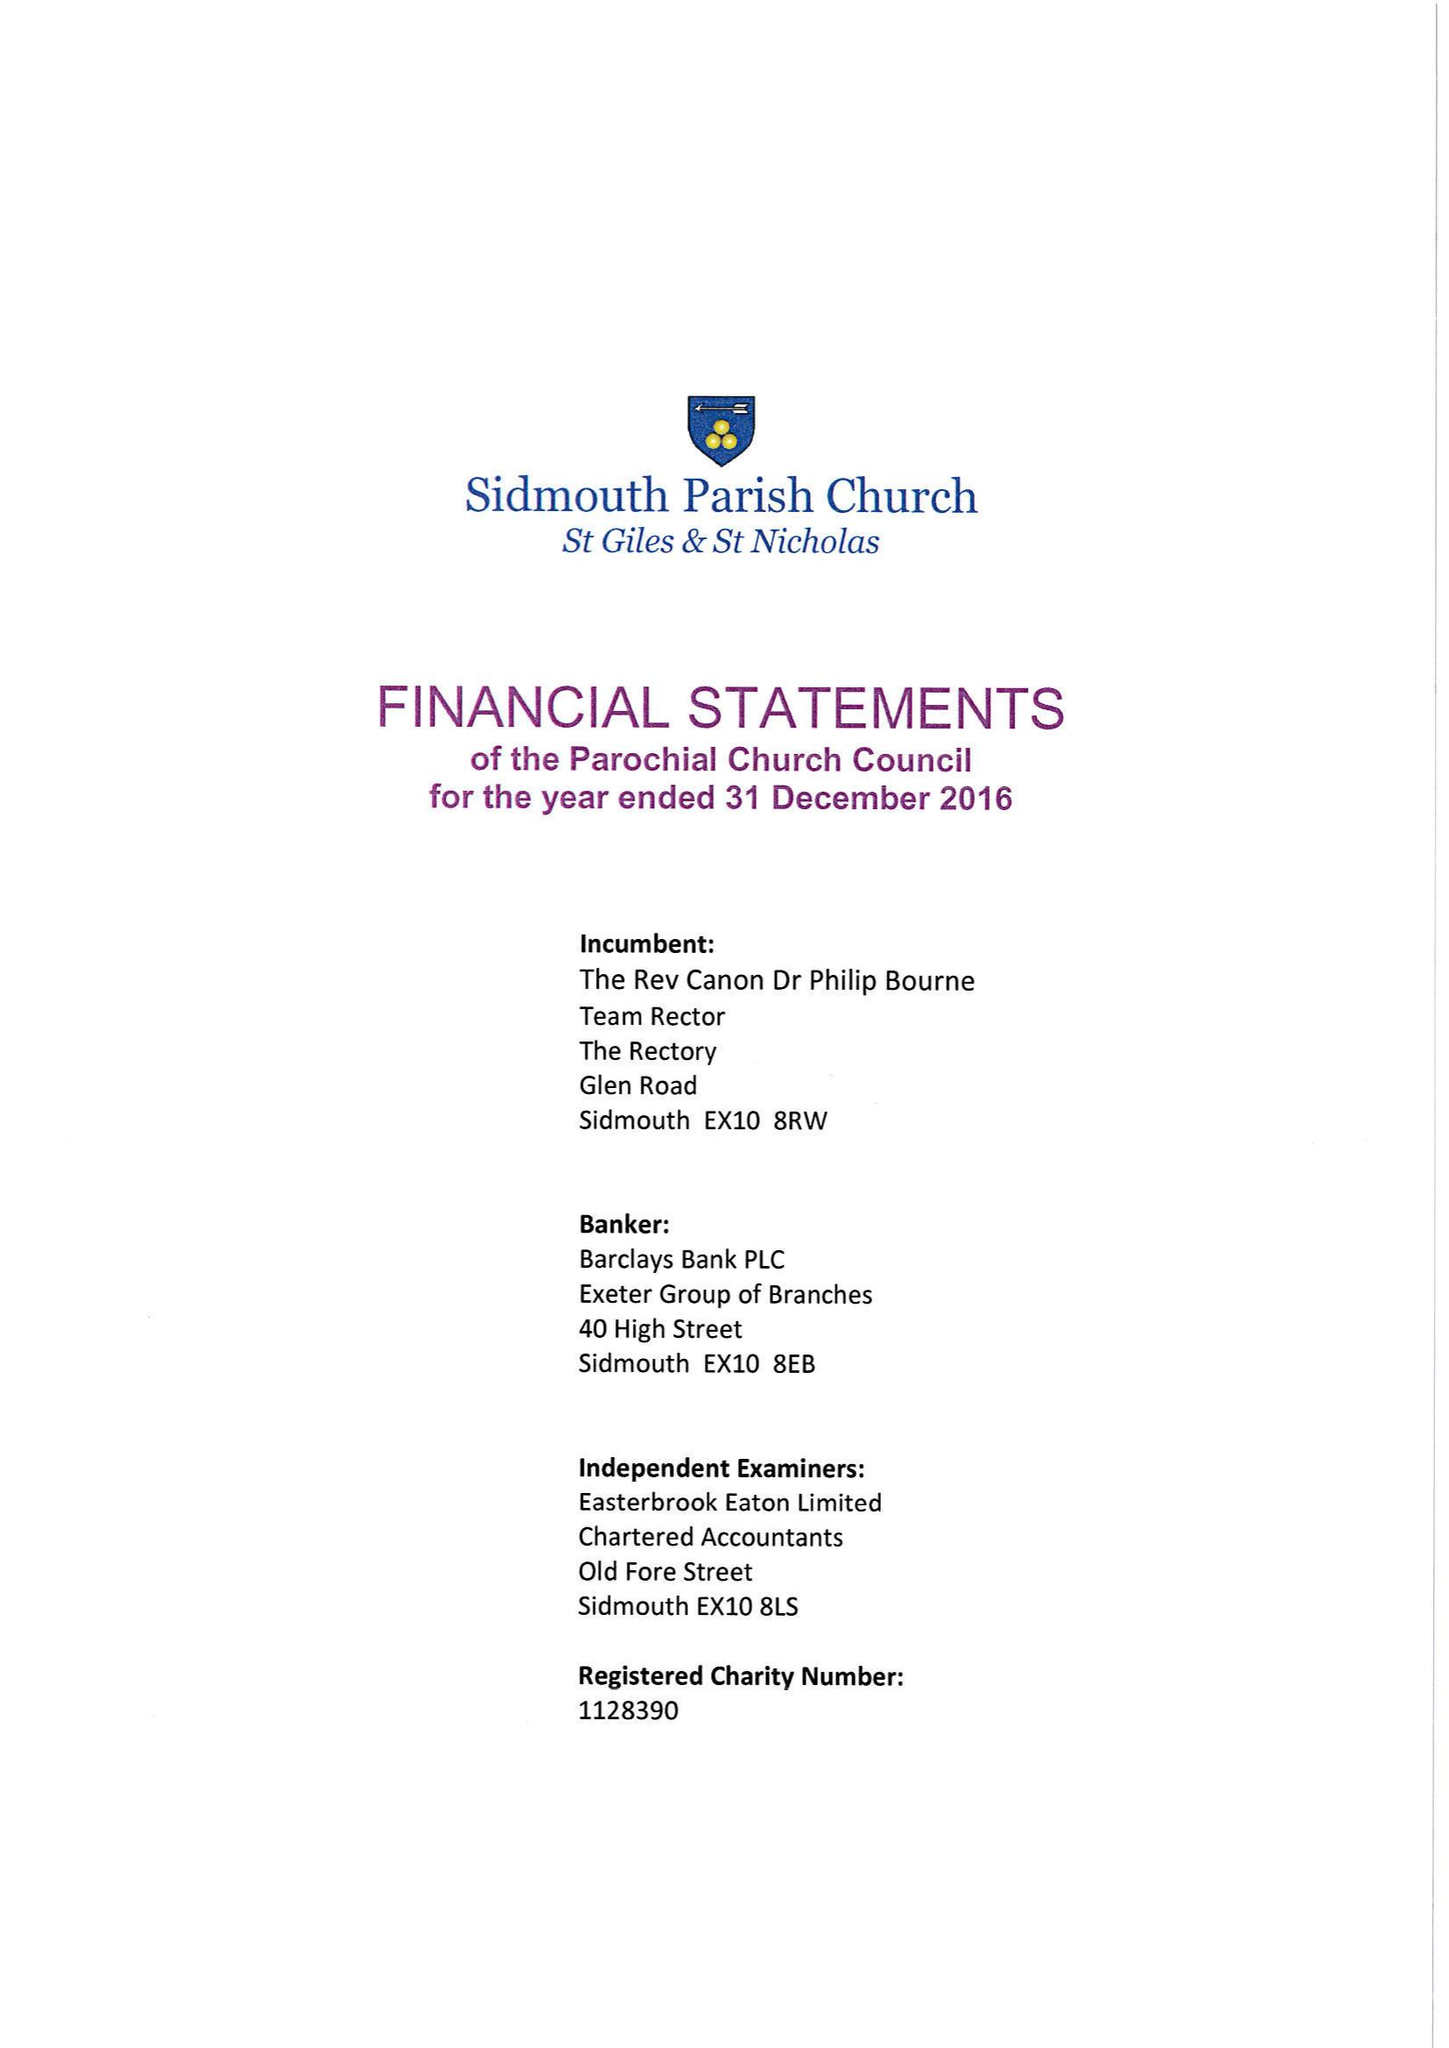What is the value for the charity_number?
Answer the question using a single word or phrase. 1128390 